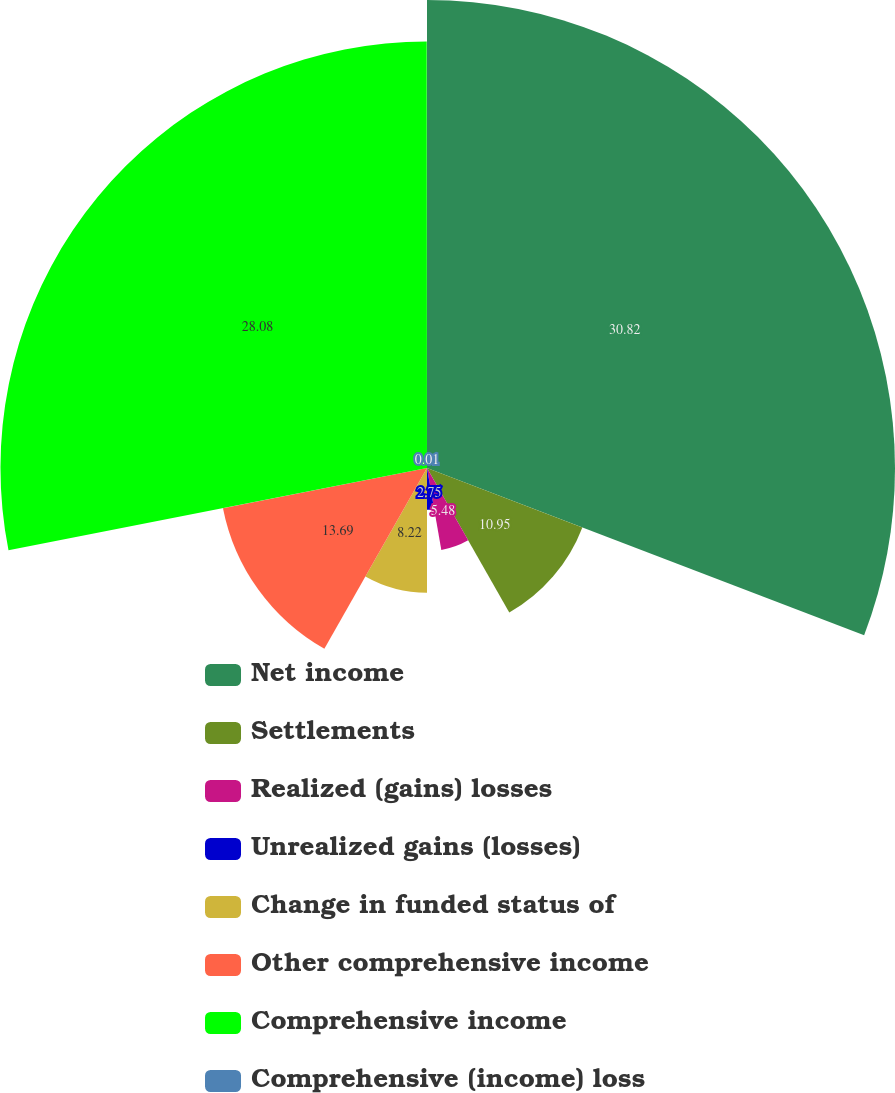Convert chart to OTSL. <chart><loc_0><loc_0><loc_500><loc_500><pie_chart><fcel>Net income<fcel>Settlements<fcel>Realized (gains) losses<fcel>Unrealized gains (losses)<fcel>Change in funded status of<fcel>Other comprehensive income<fcel>Comprehensive income<fcel>Comprehensive (income) loss<nl><fcel>30.81%<fcel>10.95%<fcel>5.48%<fcel>2.75%<fcel>8.22%<fcel>13.69%<fcel>28.08%<fcel>0.01%<nl></chart> 